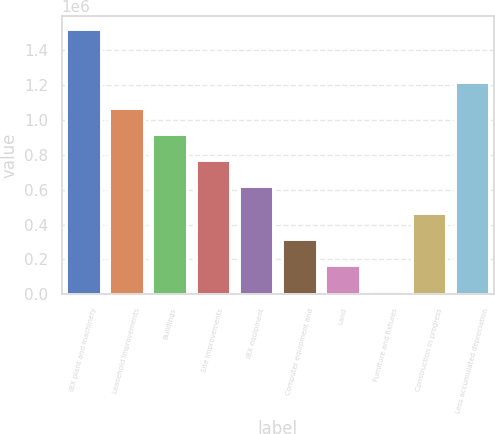Convert chart to OTSL. <chart><loc_0><loc_0><loc_500><loc_500><bar_chart><fcel>IBX plant and machinery<fcel>Leasehold improvements<fcel>Buildings<fcel>Site improvements<fcel>IBX equipment<fcel>Computer equipment and<fcel>Land<fcel>Furniture and fixtures<fcel>Construction in progress<fcel>Less accumulated depreciation<nl><fcel>1.52256e+06<fcel>1.07047e+06<fcel>919777<fcel>769082<fcel>618386<fcel>316994<fcel>166298<fcel>15602<fcel>467690<fcel>1.22117e+06<nl></chart> 